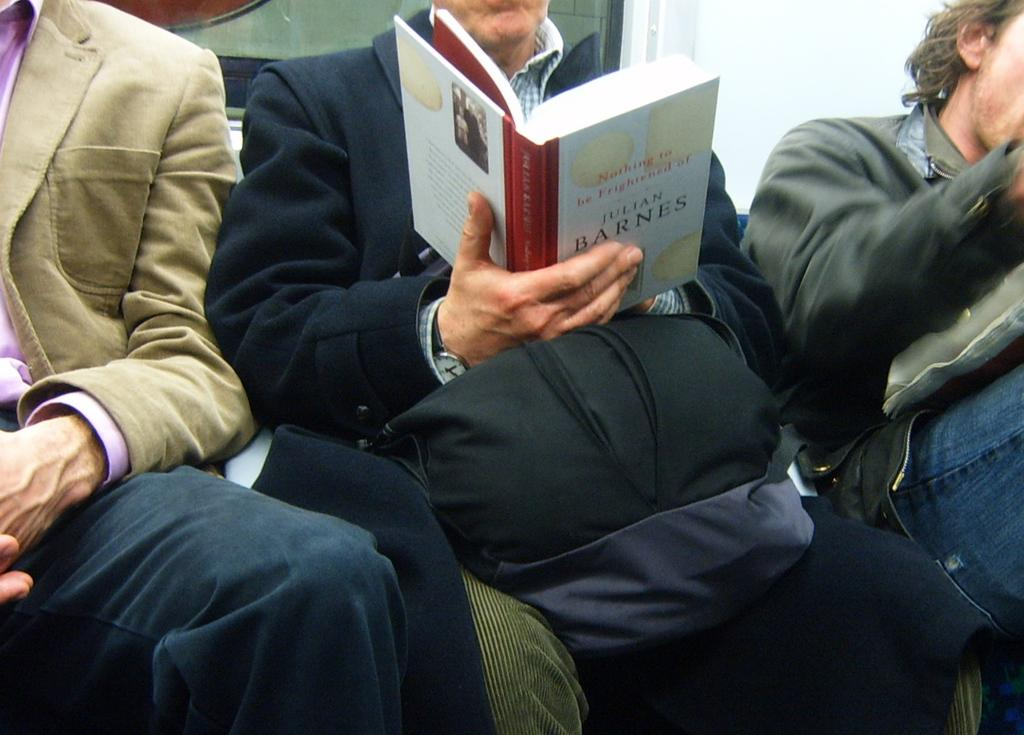What is the man in the middle of the image doing? The man in the middle of the image is sitting on a chair. What is the man in the middle of the image holding? The man in the middle of the image is holding a backpack and a book. How many other men are sitting on chairs in the image? There are four other men sitting on chairs in the image, two on the left side and two on the right side. What type of plants are growing on the man's backpack in the image? There are no plants visible on the man's backpack in the image. 